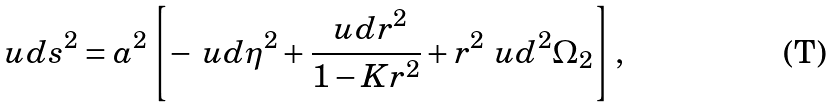Convert formula to latex. <formula><loc_0><loc_0><loc_500><loc_500>\ u d s ^ { 2 } = a ^ { 2 } \left [ - \ u d \eta ^ { 2 } + \frac { \ u d r ^ { 2 } } { 1 - K r ^ { 2 } } + r ^ { 2 } \ u d ^ { 2 } \Omega _ { 2 } \right ] ,</formula> 